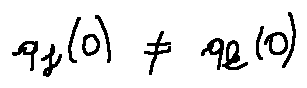<formula> <loc_0><loc_0><loc_500><loc_500>q _ { j } ( 0 ) \neq q _ { k } ( 0 )</formula> 